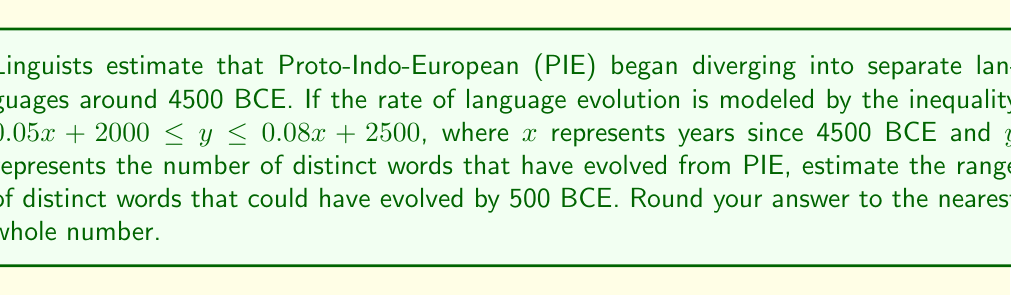Help me with this question. 1. First, we need to calculate the value of $x$ for 500 BCE:
   Years from 4500 BCE to 500 BCE = 4500 - 500 = 4000 years
   So, $x = 4000$

2. Now, we substitute $x = 4000$ into both sides of the inequality:
   $0.05(4000) + 2000 \leq y \leq 0.08(4000) + 2500$

3. Let's solve the left side of the inequality:
   $0.05(4000) + 2000 = 200 + 2000 = 2200$

4. Now, let's solve the right side of the inequality:
   $0.08(4000) + 2500 = 320 + 2500 = 2820$

5. Our inequality now looks like this:
   $2200 \leq y \leq 2820$

6. This means the number of distinct words that could have evolved by 500 BCE is between 2200 and 2820.

7. As we need to round to the nearest whole number, our final answer is 2200 to 2820.
Answer: 2200 to 2820 